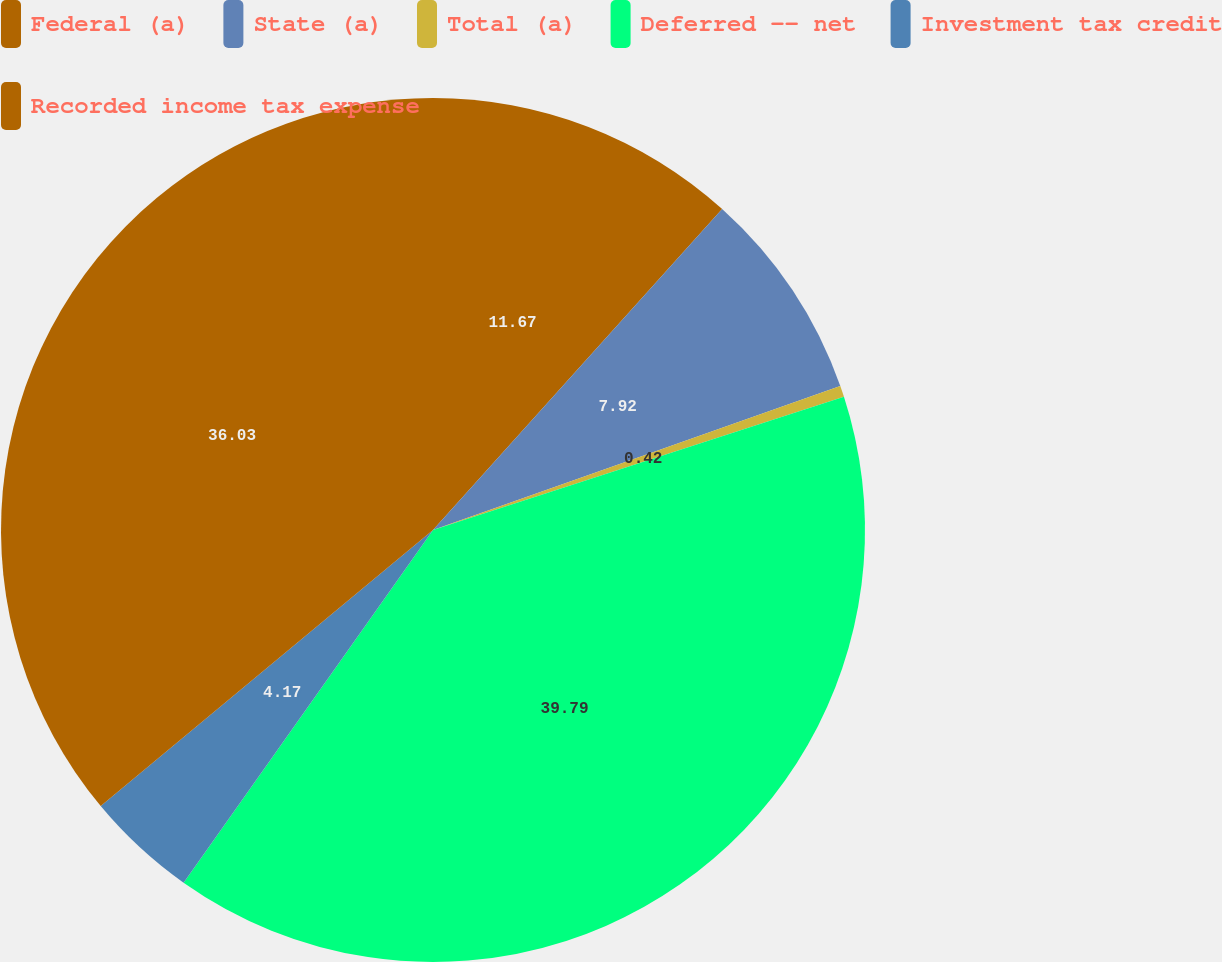<chart> <loc_0><loc_0><loc_500><loc_500><pie_chart><fcel>Federal (a)<fcel>State (a)<fcel>Total (a)<fcel>Deferred -- net<fcel>Investment tax credit<fcel>Recorded income tax expense<nl><fcel>11.67%<fcel>7.92%<fcel>0.42%<fcel>39.78%<fcel>4.17%<fcel>36.03%<nl></chart> 